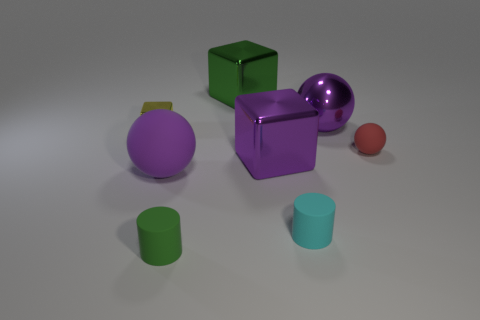Do the yellow thing and the big green shiny object have the same shape?
Make the answer very short. Yes. What is the material of the block that is the same color as the big metal sphere?
Offer a terse response. Metal. What is the yellow block made of?
Provide a succinct answer. Metal. Are there any cyan rubber objects that have the same size as the red thing?
Provide a succinct answer. Yes. Are the large cube that is in front of the small metallic thing and the small yellow object made of the same material?
Ensure brevity in your answer.  Yes. Is the number of green metallic blocks that are on the left side of the small green object the same as the number of big cubes to the right of the big green shiny object?
Ensure brevity in your answer.  No. The small object that is to the right of the big purple rubber sphere and behind the large purple rubber ball has what shape?
Offer a terse response. Sphere. There is a tiny green rubber thing; how many tiny red matte things are to the left of it?
Provide a short and direct response. 0. What number of other objects are the same shape as the small shiny object?
Your response must be concise. 2. Is the number of matte things less than the number of things?
Provide a short and direct response. Yes. 